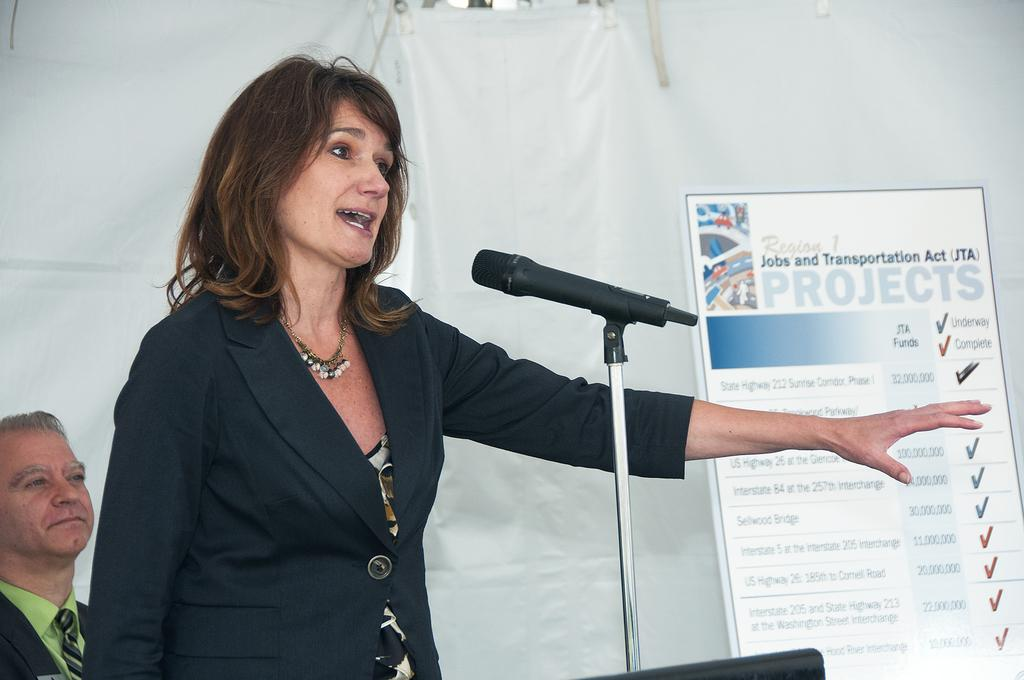Who is the main subject in the image? There is a woman in the image. What is the woman wearing? The woman is wearing a blazer. What is the woman doing in the image? The woman is speaking on a mic. Can you describe the man in the background of the image? The man in the background is smiling. What is present in the background of the image? There is a banner in the background of the image. What type of nerve can be seen in the image? There is no nerve present in the image. What kind of apparel is the mint wearing in the image? There is no mint or any reference to apparel in the image. 